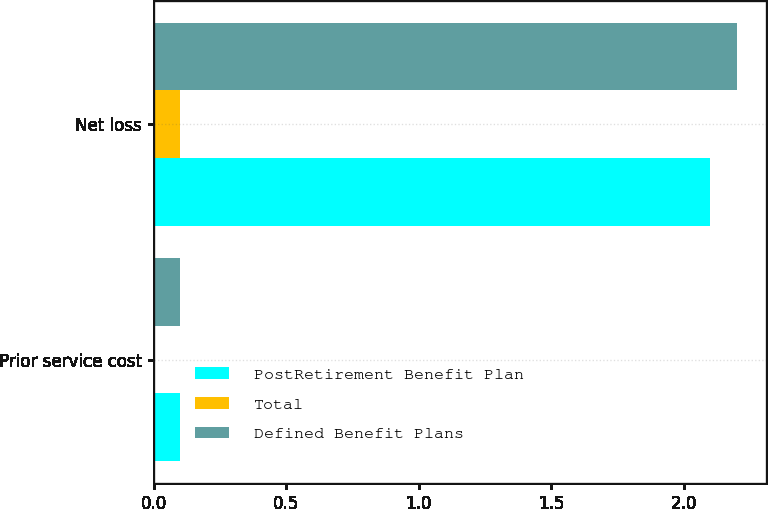Convert chart to OTSL. <chart><loc_0><loc_0><loc_500><loc_500><stacked_bar_chart><ecel><fcel>Prior service cost<fcel>Net loss<nl><fcel>PostRetirement Benefit Plan<fcel>0.1<fcel>2.1<nl><fcel>Total<fcel>0<fcel>0.1<nl><fcel>Defined Benefit Plans<fcel>0.1<fcel>2.2<nl></chart> 